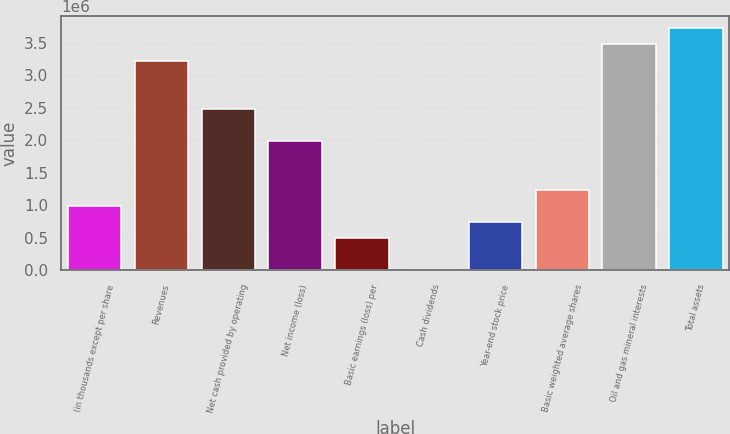Convert chart. <chart><loc_0><loc_0><loc_500><loc_500><bar_chart><fcel>(in thousands except per share<fcel>Revenues<fcel>Net cash provided by operating<fcel>Net income (loss)<fcel>Basic earnings (loss) per<fcel>Cash dividends<fcel>Year-end stock price<fcel>Basic weighted average shares<fcel>Oil and gas mineral interests<fcel>Total assets<nl><fcel>991939<fcel>3.2238e+06<fcel>2.47985e+06<fcel>1.98388e+06<fcel>495970<fcel>0.16<fcel>743954<fcel>1.23992e+06<fcel>3.47179e+06<fcel>3.71977e+06<nl></chart> 